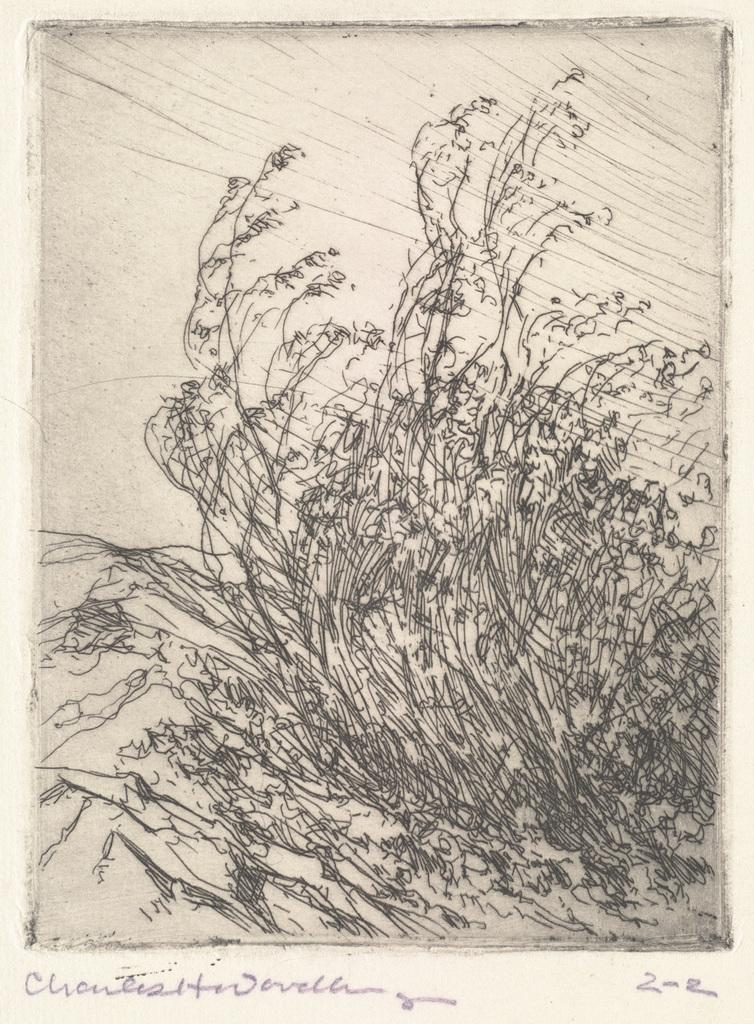What type of art is depicted in the image? There is a sketch art in the picture. Is there any text associated with the sketch art? Yes, there is text written at the bottom of the image. How many family members can be seen riding bikes in the image? There are no family members or bikes present in the image; it features a sketch art with text at the bottom. 